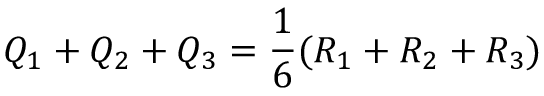Convert formula to latex. <formula><loc_0><loc_0><loc_500><loc_500>Q _ { 1 } + Q _ { 2 } + Q _ { 3 } = \frac { 1 } { 6 } ( R _ { 1 } + R _ { 2 } + R _ { 3 } )</formula> 